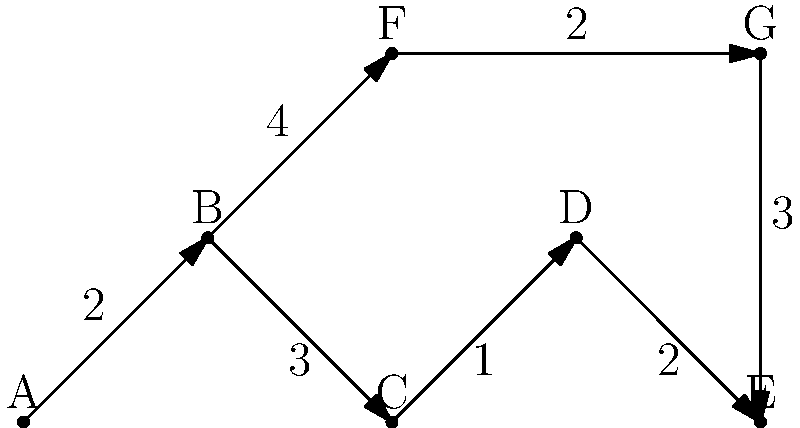In this antique shop layout, each node represents a room, and the edges represent passageways between rooms. The numbers on the edges indicate the time (in minutes) it takes to move between rooms. What is the shortest path from room A to room E, and how long does it take? To find the shortest path from room A to room E, we need to consider all possible paths and their total times:

1. Path A-B-C-D-E:
   Time = 2 + 3 + 1 + 2 = 8 minutes

2. Path A-B-F-G-E:
   Time = 2 + 4 + 2 + 3 = 11 minutes

The shortest path is A-B-C-D-E, which takes 8 minutes.

Step-by-step explanation:
1. Start at room A.
2. Move to room B (2 minutes).
3. Move to room C (3 minutes).
4. Move to room D (1 minute).
5. Finally, move to room E (2 minutes).

The alternative path through rooms F and G takes longer (11 minutes), so it's not the optimal route.
Answer: A-B-C-D-E, 8 minutes 